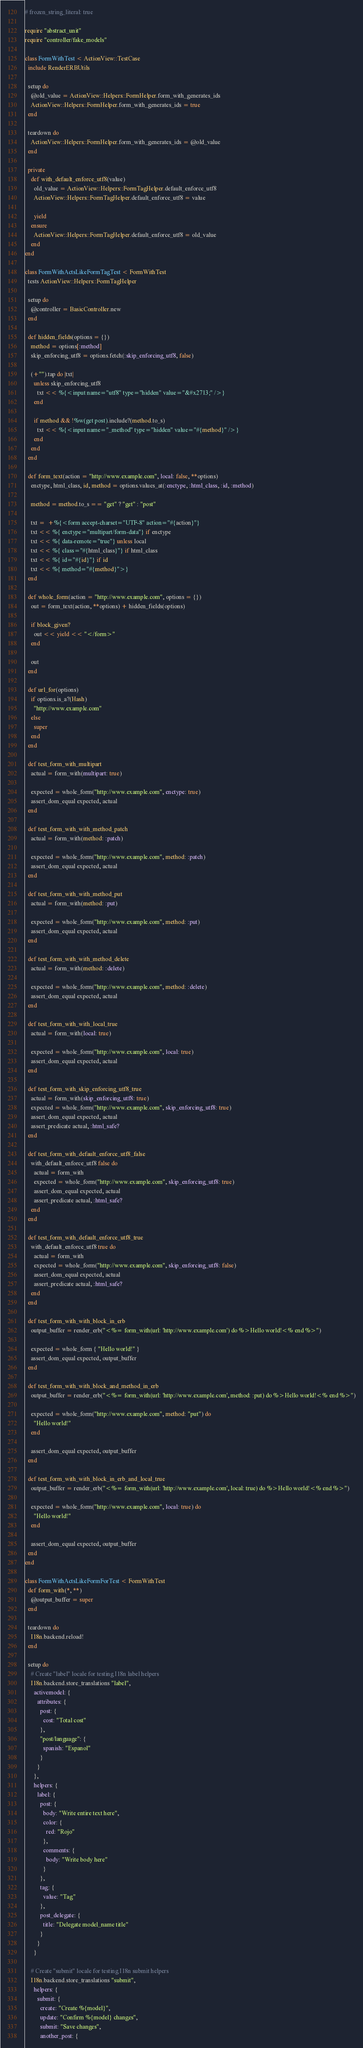Convert code to text. <code><loc_0><loc_0><loc_500><loc_500><_Ruby_># frozen_string_literal: true

require "abstract_unit"
require "controller/fake_models"

class FormWithTest < ActionView::TestCase
  include RenderERBUtils

  setup do
    @old_value = ActionView::Helpers::FormHelper.form_with_generates_ids
    ActionView::Helpers::FormHelper.form_with_generates_ids = true
  end

  teardown do
    ActionView::Helpers::FormHelper.form_with_generates_ids = @old_value
  end

  private
    def with_default_enforce_utf8(value)
      old_value = ActionView::Helpers::FormTagHelper.default_enforce_utf8
      ActionView::Helpers::FormTagHelper.default_enforce_utf8 = value

      yield
    ensure
      ActionView::Helpers::FormTagHelper.default_enforce_utf8 = old_value
    end
end

class FormWithActsLikeFormTagTest < FormWithTest
  tests ActionView::Helpers::FormTagHelper

  setup do
    @controller = BasicController.new
  end

  def hidden_fields(options = {})
    method = options[:method]
    skip_enforcing_utf8 = options.fetch(:skip_enforcing_utf8, false)

    (+"").tap do |txt|
      unless skip_enforcing_utf8
        txt << %{<input name="utf8" type="hidden" value="&#x2713;" />}
      end

      if method && !%w(get post).include?(method.to_s)
        txt << %{<input name="_method" type="hidden" value="#{method}" />}
      end
    end
  end

  def form_text(action = "http://www.example.com", local: false, **options)
    enctype, html_class, id, method = options.values_at(:enctype, :html_class, :id, :method)

    method = method.to_s == "get" ? "get" : "post"

    txt =  +%{<form accept-charset="UTF-8" action="#{action}"}
    txt << %{ enctype="multipart/form-data"} if enctype
    txt << %{ data-remote="true"} unless local
    txt << %{ class="#{html_class}"} if html_class
    txt << %{ id="#{id}"} if id
    txt << %{ method="#{method}">}
  end

  def whole_form(action = "http://www.example.com", options = {})
    out = form_text(action, **options) + hidden_fields(options)

    if block_given?
      out << yield << "</form>"
    end

    out
  end

  def url_for(options)
    if options.is_a?(Hash)
      "http://www.example.com"
    else
      super
    end
  end

  def test_form_with_multipart
    actual = form_with(multipart: true)

    expected = whole_form("http://www.example.com", enctype: true)
    assert_dom_equal expected, actual
  end

  def test_form_with_with_method_patch
    actual = form_with(method: :patch)

    expected = whole_form("http://www.example.com", method: :patch)
    assert_dom_equal expected, actual
  end

  def test_form_with_with_method_put
    actual = form_with(method: :put)

    expected = whole_form("http://www.example.com", method: :put)
    assert_dom_equal expected, actual
  end

  def test_form_with_with_method_delete
    actual = form_with(method: :delete)

    expected = whole_form("http://www.example.com", method: :delete)
    assert_dom_equal expected, actual
  end

  def test_form_with_with_local_true
    actual = form_with(local: true)

    expected = whole_form("http://www.example.com", local: true)
    assert_dom_equal expected, actual
  end

  def test_form_with_skip_enforcing_utf8_true
    actual = form_with(skip_enforcing_utf8: true)
    expected = whole_form("http://www.example.com", skip_enforcing_utf8: true)
    assert_dom_equal expected, actual
    assert_predicate actual, :html_safe?
  end

  def test_form_with_default_enforce_utf8_false
    with_default_enforce_utf8 false do
      actual = form_with
      expected = whole_form("http://www.example.com", skip_enforcing_utf8: true)
      assert_dom_equal expected, actual
      assert_predicate actual, :html_safe?
    end
  end

  def test_form_with_default_enforce_utf8_true
    with_default_enforce_utf8 true do
      actual = form_with
      expected = whole_form("http://www.example.com", skip_enforcing_utf8: false)
      assert_dom_equal expected, actual
      assert_predicate actual, :html_safe?
    end
  end

  def test_form_with_with_block_in_erb
    output_buffer = render_erb("<%= form_with(url: 'http://www.example.com') do %>Hello world!<% end %>")

    expected = whole_form { "Hello world!" }
    assert_dom_equal expected, output_buffer
  end

  def test_form_with_with_block_and_method_in_erb
    output_buffer = render_erb("<%= form_with(url: 'http://www.example.com', method: :put) do %>Hello world!<% end %>")

    expected = whole_form("http://www.example.com", method: "put") do
      "Hello world!"
    end

    assert_dom_equal expected, output_buffer
  end

  def test_form_with_with_block_in_erb_and_local_true
    output_buffer = render_erb("<%= form_with(url: 'http://www.example.com', local: true) do %>Hello world!<% end %>")

    expected = whole_form("http://www.example.com", local: true) do
      "Hello world!"
    end

    assert_dom_equal expected, output_buffer
  end
end

class FormWithActsLikeFormForTest < FormWithTest
  def form_with(*, **)
    @output_buffer = super
  end

  teardown do
    I18n.backend.reload!
  end

  setup do
    # Create "label" locale for testing I18n label helpers
    I18n.backend.store_translations "label",
      activemodel: {
        attributes: {
          post: {
            cost: "Total cost"
          },
          "post/language": {
            spanish: "Espanol"
          }
        }
      },
      helpers: {
        label: {
          post: {
            body: "Write entire text here",
            color: {
              red: "Rojo"
            },
            comments: {
              body: "Write body here"
            }
          },
          tag: {
            value: "Tag"
          },
          post_delegate: {
            title: "Delegate model_name title"
          }
        }
      }

    # Create "submit" locale for testing I18n submit helpers
    I18n.backend.store_translations "submit",
      helpers: {
        submit: {
          create: "Create %{model}",
          update: "Confirm %{model} changes",
          submit: "Save changes",
          another_post: {</code> 